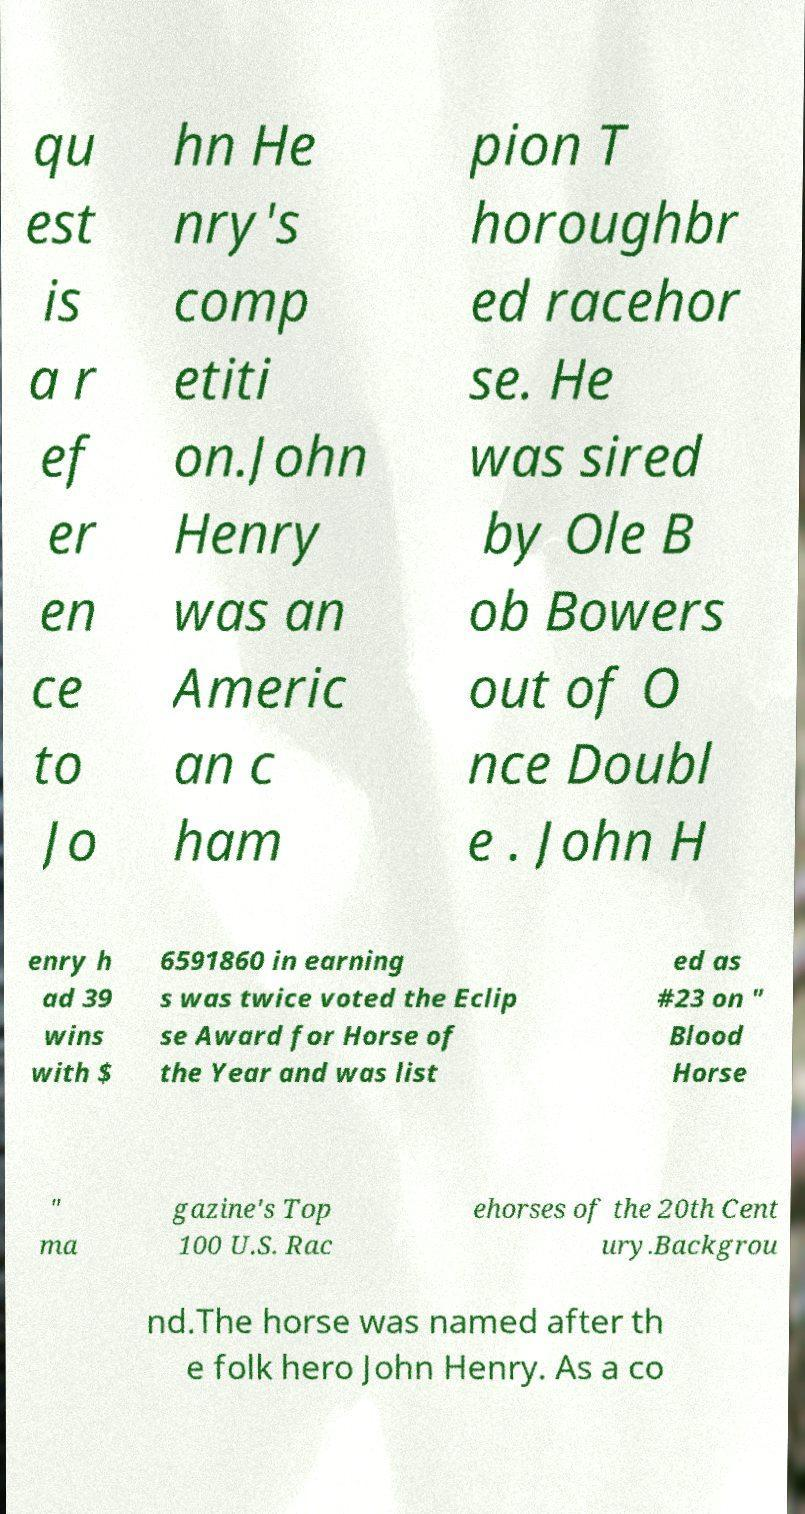For documentation purposes, I need the text within this image transcribed. Could you provide that? qu est is a r ef er en ce to Jo hn He nry's comp etiti on.John Henry was an Americ an c ham pion T horoughbr ed racehor se. He was sired by Ole B ob Bowers out of O nce Doubl e . John H enry h ad 39 wins with $ 6591860 in earning s was twice voted the Eclip se Award for Horse of the Year and was list ed as #23 on " Blood Horse " ma gazine's Top 100 U.S. Rac ehorses of the 20th Cent ury.Backgrou nd.The horse was named after th e folk hero John Henry. As a co 